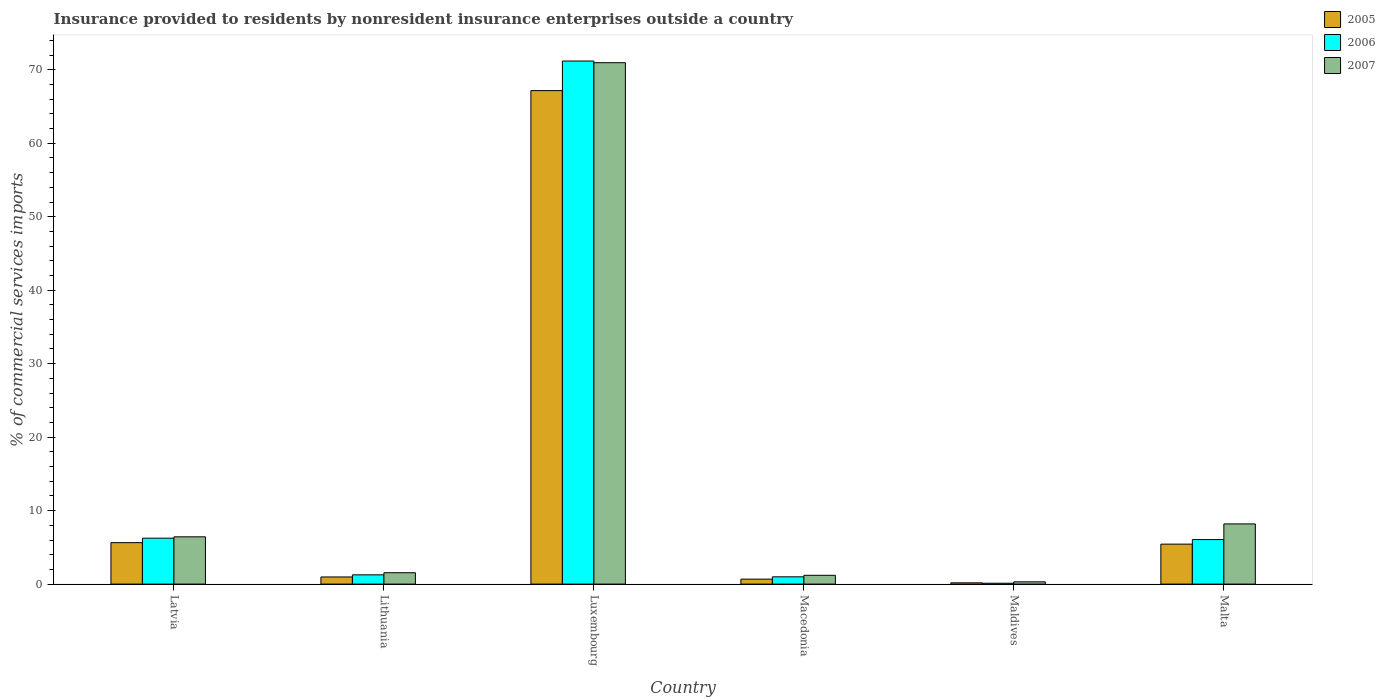Are the number of bars on each tick of the X-axis equal?
Offer a terse response. Yes. How many bars are there on the 3rd tick from the left?
Your answer should be very brief. 3. How many bars are there on the 2nd tick from the right?
Your answer should be very brief. 3. What is the label of the 1st group of bars from the left?
Offer a terse response. Latvia. What is the Insurance provided to residents in 2005 in Luxembourg?
Give a very brief answer. 67.16. Across all countries, what is the maximum Insurance provided to residents in 2006?
Give a very brief answer. 71.19. Across all countries, what is the minimum Insurance provided to residents in 2005?
Give a very brief answer. 0.17. In which country was the Insurance provided to residents in 2006 maximum?
Your answer should be very brief. Luxembourg. In which country was the Insurance provided to residents in 2006 minimum?
Your response must be concise. Maldives. What is the total Insurance provided to residents in 2007 in the graph?
Keep it short and to the point. 88.64. What is the difference between the Insurance provided to residents in 2006 in Maldives and that in Malta?
Give a very brief answer. -5.94. What is the difference between the Insurance provided to residents in 2007 in Macedonia and the Insurance provided to residents in 2006 in Maldives?
Your answer should be very brief. 1.08. What is the average Insurance provided to residents in 2005 per country?
Your answer should be compact. 13.34. What is the difference between the Insurance provided to residents of/in 2006 and Insurance provided to residents of/in 2007 in Luxembourg?
Keep it short and to the point. 0.23. What is the ratio of the Insurance provided to residents in 2005 in Latvia to that in Luxembourg?
Offer a terse response. 0.08. Is the difference between the Insurance provided to residents in 2006 in Macedonia and Malta greater than the difference between the Insurance provided to residents in 2007 in Macedonia and Malta?
Give a very brief answer. Yes. What is the difference between the highest and the second highest Insurance provided to residents in 2005?
Offer a very short reply. -61.72. What is the difference between the highest and the lowest Insurance provided to residents in 2007?
Make the answer very short. 70.65. In how many countries, is the Insurance provided to residents in 2007 greater than the average Insurance provided to residents in 2007 taken over all countries?
Make the answer very short. 1. What does the 3rd bar from the right in Maldives represents?
Your response must be concise. 2005. Is it the case that in every country, the sum of the Insurance provided to residents in 2006 and Insurance provided to residents in 2005 is greater than the Insurance provided to residents in 2007?
Your answer should be very brief. No. How many countries are there in the graph?
Keep it short and to the point. 6. Where does the legend appear in the graph?
Ensure brevity in your answer.  Top right. How many legend labels are there?
Ensure brevity in your answer.  3. What is the title of the graph?
Your response must be concise. Insurance provided to residents by nonresident insurance enterprises outside a country. What is the label or title of the Y-axis?
Give a very brief answer. % of commercial services imports. What is the % of commercial services imports of 2005 in Latvia?
Give a very brief answer. 5.64. What is the % of commercial services imports of 2006 in Latvia?
Provide a succinct answer. 6.25. What is the % of commercial services imports of 2007 in Latvia?
Keep it short and to the point. 6.44. What is the % of commercial services imports of 2005 in Lithuania?
Keep it short and to the point. 0.97. What is the % of commercial services imports in 2006 in Lithuania?
Keep it short and to the point. 1.26. What is the % of commercial services imports of 2007 in Lithuania?
Your answer should be very brief. 1.55. What is the % of commercial services imports of 2005 in Luxembourg?
Your response must be concise. 67.16. What is the % of commercial services imports in 2006 in Luxembourg?
Your answer should be compact. 71.19. What is the % of commercial services imports of 2007 in Luxembourg?
Keep it short and to the point. 70.96. What is the % of commercial services imports of 2005 in Macedonia?
Give a very brief answer. 0.68. What is the % of commercial services imports in 2006 in Macedonia?
Your answer should be compact. 0.99. What is the % of commercial services imports of 2007 in Macedonia?
Provide a succinct answer. 1.2. What is the % of commercial services imports of 2005 in Maldives?
Keep it short and to the point. 0.17. What is the % of commercial services imports of 2006 in Maldives?
Ensure brevity in your answer.  0.12. What is the % of commercial services imports in 2007 in Maldives?
Your answer should be very brief. 0.31. What is the % of commercial services imports of 2005 in Malta?
Make the answer very short. 5.44. What is the % of commercial services imports of 2006 in Malta?
Provide a short and direct response. 6.06. What is the % of commercial services imports of 2007 in Malta?
Your response must be concise. 8.19. Across all countries, what is the maximum % of commercial services imports in 2005?
Ensure brevity in your answer.  67.16. Across all countries, what is the maximum % of commercial services imports of 2006?
Your answer should be very brief. 71.19. Across all countries, what is the maximum % of commercial services imports in 2007?
Ensure brevity in your answer.  70.96. Across all countries, what is the minimum % of commercial services imports in 2005?
Your answer should be very brief. 0.17. Across all countries, what is the minimum % of commercial services imports of 2006?
Provide a short and direct response. 0.12. Across all countries, what is the minimum % of commercial services imports in 2007?
Keep it short and to the point. 0.31. What is the total % of commercial services imports in 2005 in the graph?
Offer a terse response. 80.06. What is the total % of commercial services imports in 2006 in the graph?
Your answer should be compact. 85.86. What is the total % of commercial services imports of 2007 in the graph?
Your response must be concise. 88.64. What is the difference between the % of commercial services imports of 2005 in Latvia and that in Lithuania?
Give a very brief answer. 4.67. What is the difference between the % of commercial services imports in 2006 in Latvia and that in Lithuania?
Provide a succinct answer. 4.99. What is the difference between the % of commercial services imports in 2007 in Latvia and that in Lithuania?
Your answer should be very brief. 4.89. What is the difference between the % of commercial services imports in 2005 in Latvia and that in Luxembourg?
Provide a short and direct response. -61.52. What is the difference between the % of commercial services imports of 2006 in Latvia and that in Luxembourg?
Ensure brevity in your answer.  -64.94. What is the difference between the % of commercial services imports of 2007 in Latvia and that in Luxembourg?
Provide a short and direct response. -64.52. What is the difference between the % of commercial services imports in 2005 in Latvia and that in Macedonia?
Your response must be concise. 4.96. What is the difference between the % of commercial services imports in 2006 in Latvia and that in Macedonia?
Ensure brevity in your answer.  5.26. What is the difference between the % of commercial services imports in 2007 in Latvia and that in Macedonia?
Your answer should be compact. 5.24. What is the difference between the % of commercial services imports in 2005 in Latvia and that in Maldives?
Your answer should be compact. 5.47. What is the difference between the % of commercial services imports in 2006 in Latvia and that in Maldives?
Ensure brevity in your answer.  6.13. What is the difference between the % of commercial services imports in 2007 in Latvia and that in Maldives?
Your answer should be very brief. 6.13. What is the difference between the % of commercial services imports in 2005 in Latvia and that in Malta?
Provide a succinct answer. 0.2. What is the difference between the % of commercial services imports in 2006 in Latvia and that in Malta?
Your response must be concise. 0.19. What is the difference between the % of commercial services imports of 2007 in Latvia and that in Malta?
Provide a short and direct response. -1.76. What is the difference between the % of commercial services imports in 2005 in Lithuania and that in Luxembourg?
Make the answer very short. -66.19. What is the difference between the % of commercial services imports in 2006 in Lithuania and that in Luxembourg?
Your answer should be very brief. -69.92. What is the difference between the % of commercial services imports of 2007 in Lithuania and that in Luxembourg?
Your response must be concise. -69.41. What is the difference between the % of commercial services imports of 2005 in Lithuania and that in Macedonia?
Keep it short and to the point. 0.3. What is the difference between the % of commercial services imports of 2006 in Lithuania and that in Macedonia?
Your response must be concise. 0.27. What is the difference between the % of commercial services imports in 2007 in Lithuania and that in Macedonia?
Offer a terse response. 0.35. What is the difference between the % of commercial services imports of 2005 in Lithuania and that in Maldives?
Offer a terse response. 0.8. What is the difference between the % of commercial services imports in 2006 in Lithuania and that in Maldives?
Ensure brevity in your answer.  1.14. What is the difference between the % of commercial services imports in 2007 in Lithuania and that in Maldives?
Provide a succinct answer. 1.24. What is the difference between the % of commercial services imports in 2005 in Lithuania and that in Malta?
Keep it short and to the point. -4.47. What is the difference between the % of commercial services imports of 2006 in Lithuania and that in Malta?
Give a very brief answer. -4.8. What is the difference between the % of commercial services imports in 2007 in Lithuania and that in Malta?
Ensure brevity in your answer.  -6.64. What is the difference between the % of commercial services imports of 2005 in Luxembourg and that in Macedonia?
Provide a succinct answer. 66.48. What is the difference between the % of commercial services imports in 2006 in Luxembourg and that in Macedonia?
Your answer should be compact. 70.19. What is the difference between the % of commercial services imports in 2007 in Luxembourg and that in Macedonia?
Offer a terse response. 69.76. What is the difference between the % of commercial services imports in 2005 in Luxembourg and that in Maldives?
Your answer should be very brief. 66.99. What is the difference between the % of commercial services imports of 2006 in Luxembourg and that in Maldives?
Your answer should be compact. 71.07. What is the difference between the % of commercial services imports of 2007 in Luxembourg and that in Maldives?
Your answer should be very brief. 70.65. What is the difference between the % of commercial services imports in 2005 in Luxembourg and that in Malta?
Offer a very short reply. 61.72. What is the difference between the % of commercial services imports in 2006 in Luxembourg and that in Malta?
Ensure brevity in your answer.  65.12. What is the difference between the % of commercial services imports in 2007 in Luxembourg and that in Malta?
Your answer should be compact. 62.77. What is the difference between the % of commercial services imports in 2005 in Macedonia and that in Maldives?
Ensure brevity in your answer.  0.5. What is the difference between the % of commercial services imports in 2006 in Macedonia and that in Maldives?
Provide a short and direct response. 0.87. What is the difference between the % of commercial services imports of 2007 in Macedonia and that in Maldives?
Your response must be concise. 0.89. What is the difference between the % of commercial services imports of 2005 in Macedonia and that in Malta?
Your answer should be compact. -4.76. What is the difference between the % of commercial services imports in 2006 in Macedonia and that in Malta?
Provide a succinct answer. -5.07. What is the difference between the % of commercial services imports of 2007 in Macedonia and that in Malta?
Ensure brevity in your answer.  -6.99. What is the difference between the % of commercial services imports in 2005 in Maldives and that in Malta?
Make the answer very short. -5.27. What is the difference between the % of commercial services imports in 2006 in Maldives and that in Malta?
Keep it short and to the point. -5.94. What is the difference between the % of commercial services imports of 2007 in Maldives and that in Malta?
Ensure brevity in your answer.  -7.88. What is the difference between the % of commercial services imports in 2005 in Latvia and the % of commercial services imports in 2006 in Lithuania?
Give a very brief answer. 4.38. What is the difference between the % of commercial services imports in 2005 in Latvia and the % of commercial services imports in 2007 in Lithuania?
Provide a short and direct response. 4.09. What is the difference between the % of commercial services imports in 2006 in Latvia and the % of commercial services imports in 2007 in Lithuania?
Your answer should be compact. 4.7. What is the difference between the % of commercial services imports in 2005 in Latvia and the % of commercial services imports in 2006 in Luxembourg?
Offer a terse response. -65.54. What is the difference between the % of commercial services imports of 2005 in Latvia and the % of commercial services imports of 2007 in Luxembourg?
Ensure brevity in your answer.  -65.32. What is the difference between the % of commercial services imports in 2006 in Latvia and the % of commercial services imports in 2007 in Luxembourg?
Offer a very short reply. -64.71. What is the difference between the % of commercial services imports of 2005 in Latvia and the % of commercial services imports of 2006 in Macedonia?
Provide a succinct answer. 4.65. What is the difference between the % of commercial services imports in 2005 in Latvia and the % of commercial services imports in 2007 in Macedonia?
Keep it short and to the point. 4.44. What is the difference between the % of commercial services imports of 2006 in Latvia and the % of commercial services imports of 2007 in Macedonia?
Your answer should be very brief. 5.05. What is the difference between the % of commercial services imports of 2005 in Latvia and the % of commercial services imports of 2006 in Maldives?
Provide a succinct answer. 5.52. What is the difference between the % of commercial services imports of 2005 in Latvia and the % of commercial services imports of 2007 in Maldives?
Offer a terse response. 5.33. What is the difference between the % of commercial services imports of 2006 in Latvia and the % of commercial services imports of 2007 in Maldives?
Provide a short and direct response. 5.94. What is the difference between the % of commercial services imports in 2005 in Latvia and the % of commercial services imports in 2006 in Malta?
Your answer should be compact. -0.42. What is the difference between the % of commercial services imports in 2005 in Latvia and the % of commercial services imports in 2007 in Malta?
Offer a terse response. -2.55. What is the difference between the % of commercial services imports in 2006 in Latvia and the % of commercial services imports in 2007 in Malta?
Provide a short and direct response. -1.94. What is the difference between the % of commercial services imports in 2005 in Lithuania and the % of commercial services imports in 2006 in Luxembourg?
Make the answer very short. -70.21. What is the difference between the % of commercial services imports of 2005 in Lithuania and the % of commercial services imports of 2007 in Luxembourg?
Your answer should be compact. -69.99. What is the difference between the % of commercial services imports in 2006 in Lithuania and the % of commercial services imports in 2007 in Luxembourg?
Your response must be concise. -69.7. What is the difference between the % of commercial services imports in 2005 in Lithuania and the % of commercial services imports in 2006 in Macedonia?
Offer a terse response. -0.02. What is the difference between the % of commercial services imports of 2005 in Lithuania and the % of commercial services imports of 2007 in Macedonia?
Give a very brief answer. -0.23. What is the difference between the % of commercial services imports of 2006 in Lithuania and the % of commercial services imports of 2007 in Macedonia?
Offer a terse response. 0.06. What is the difference between the % of commercial services imports of 2005 in Lithuania and the % of commercial services imports of 2006 in Maldives?
Offer a very short reply. 0.85. What is the difference between the % of commercial services imports in 2005 in Lithuania and the % of commercial services imports in 2007 in Maldives?
Provide a short and direct response. 0.66. What is the difference between the % of commercial services imports of 2006 in Lithuania and the % of commercial services imports of 2007 in Maldives?
Offer a very short reply. 0.95. What is the difference between the % of commercial services imports of 2005 in Lithuania and the % of commercial services imports of 2006 in Malta?
Offer a terse response. -5.09. What is the difference between the % of commercial services imports in 2005 in Lithuania and the % of commercial services imports in 2007 in Malta?
Provide a succinct answer. -7.22. What is the difference between the % of commercial services imports in 2006 in Lithuania and the % of commercial services imports in 2007 in Malta?
Provide a succinct answer. -6.93. What is the difference between the % of commercial services imports of 2005 in Luxembourg and the % of commercial services imports of 2006 in Macedonia?
Make the answer very short. 66.17. What is the difference between the % of commercial services imports of 2005 in Luxembourg and the % of commercial services imports of 2007 in Macedonia?
Make the answer very short. 65.96. What is the difference between the % of commercial services imports in 2006 in Luxembourg and the % of commercial services imports in 2007 in Macedonia?
Your answer should be compact. 69.99. What is the difference between the % of commercial services imports in 2005 in Luxembourg and the % of commercial services imports in 2006 in Maldives?
Make the answer very short. 67.04. What is the difference between the % of commercial services imports of 2005 in Luxembourg and the % of commercial services imports of 2007 in Maldives?
Provide a succinct answer. 66.85. What is the difference between the % of commercial services imports of 2006 in Luxembourg and the % of commercial services imports of 2007 in Maldives?
Your response must be concise. 70.88. What is the difference between the % of commercial services imports of 2005 in Luxembourg and the % of commercial services imports of 2006 in Malta?
Offer a very short reply. 61.1. What is the difference between the % of commercial services imports of 2005 in Luxembourg and the % of commercial services imports of 2007 in Malta?
Give a very brief answer. 58.97. What is the difference between the % of commercial services imports of 2006 in Luxembourg and the % of commercial services imports of 2007 in Malta?
Give a very brief answer. 62.99. What is the difference between the % of commercial services imports in 2005 in Macedonia and the % of commercial services imports in 2006 in Maldives?
Your answer should be compact. 0.56. What is the difference between the % of commercial services imports of 2005 in Macedonia and the % of commercial services imports of 2007 in Maldives?
Offer a terse response. 0.37. What is the difference between the % of commercial services imports of 2006 in Macedonia and the % of commercial services imports of 2007 in Maldives?
Offer a very short reply. 0.68. What is the difference between the % of commercial services imports of 2005 in Macedonia and the % of commercial services imports of 2006 in Malta?
Your answer should be very brief. -5.38. What is the difference between the % of commercial services imports of 2005 in Macedonia and the % of commercial services imports of 2007 in Malta?
Provide a short and direct response. -7.52. What is the difference between the % of commercial services imports in 2006 in Macedonia and the % of commercial services imports in 2007 in Malta?
Your answer should be very brief. -7.2. What is the difference between the % of commercial services imports of 2005 in Maldives and the % of commercial services imports of 2006 in Malta?
Your answer should be compact. -5.89. What is the difference between the % of commercial services imports of 2005 in Maldives and the % of commercial services imports of 2007 in Malta?
Your answer should be compact. -8.02. What is the difference between the % of commercial services imports of 2006 in Maldives and the % of commercial services imports of 2007 in Malta?
Ensure brevity in your answer.  -8.07. What is the average % of commercial services imports in 2005 per country?
Give a very brief answer. 13.34. What is the average % of commercial services imports in 2006 per country?
Give a very brief answer. 14.31. What is the average % of commercial services imports in 2007 per country?
Make the answer very short. 14.77. What is the difference between the % of commercial services imports in 2005 and % of commercial services imports in 2006 in Latvia?
Keep it short and to the point. -0.61. What is the difference between the % of commercial services imports of 2005 and % of commercial services imports of 2007 in Latvia?
Give a very brief answer. -0.79. What is the difference between the % of commercial services imports in 2006 and % of commercial services imports in 2007 in Latvia?
Ensure brevity in your answer.  -0.19. What is the difference between the % of commercial services imports of 2005 and % of commercial services imports of 2006 in Lithuania?
Ensure brevity in your answer.  -0.29. What is the difference between the % of commercial services imports of 2005 and % of commercial services imports of 2007 in Lithuania?
Your answer should be compact. -0.57. What is the difference between the % of commercial services imports of 2006 and % of commercial services imports of 2007 in Lithuania?
Your answer should be compact. -0.29. What is the difference between the % of commercial services imports of 2005 and % of commercial services imports of 2006 in Luxembourg?
Your response must be concise. -4.03. What is the difference between the % of commercial services imports of 2005 and % of commercial services imports of 2007 in Luxembourg?
Ensure brevity in your answer.  -3.8. What is the difference between the % of commercial services imports of 2006 and % of commercial services imports of 2007 in Luxembourg?
Your answer should be very brief. 0.23. What is the difference between the % of commercial services imports of 2005 and % of commercial services imports of 2006 in Macedonia?
Your answer should be very brief. -0.31. What is the difference between the % of commercial services imports of 2005 and % of commercial services imports of 2007 in Macedonia?
Provide a succinct answer. -0.52. What is the difference between the % of commercial services imports in 2006 and % of commercial services imports in 2007 in Macedonia?
Your answer should be very brief. -0.21. What is the difference between the % of commercial services imports in 2005 and % of commercial services imports in 2006 in Maldives?
Your answer should be compact. 0.05. What is the difference between the % of commercial services imports in 2005 and % of commercial services imports in 2007 in Maldives?
Your answer should be very brief. -0.14. What is the difference between the % of commercial services imports of 2006 and % of commercial services imports of 2007 in Maldives?
Provide a succinct answer. -0.19. What is the difference between the % of commercial services imports of 2005 and % of commercial services imports of 2006 in Malta?
Make the answer very short. -0.62. What is the difference between the % of commercial services imports of 2005 and % of commercial services imports of 2007 in Malta?
Keep it short and to the point. -2.75. What is the difference between the % of commercial services imports of 2006 and % of commercial services imports of 2007 in Malta?
Make the answer very short. -2.13. What is the ratio of the % of commercial services imports in 2005 in Latvia to that in Lithuania?
Keep it short and to the point. 5.8. What is the ratio of the % of commercial services imports of 2006 in Latvia to that in Lithuania?
Keep it short and to the point. 4.96. What is the ratio of the % of commercial services imports in 2007 in Latvia to that in Lithuania?
Your answer should be compact. 4.16. What is the ratio of the % of commercial services imports of 2005 in Latvia to that in Luxembourg?
Your answer should be compact. 0.08. What is the ratio of the % of commercial services imports of 2006 in Latvia to that in Luxembourg?
Your response must be concise. 0.09. What is the ratio of the % of commercial services imports in 2007 in Latvia to that in Luxembourg?
Make the answer very short. 0.09. What is the ratio of the % of commercial services imports in 2005 in Latvia to that in Macedonia?
Your answer should be compact. 8.34. What is the ratio of the % of commercial services imports in 2006 in Latvia to that in Macedonia?
Your answer should be very brief. 6.31. What is the ratio of the % of commercial services imports in 2007 in Latvia to that in Macedonia?
Provide a succinct answer. 5.37. What is the ratio of the % of commercial services imports of 2005 in Latvia to that in Maldives?
Offer a terse response. 32.8. What is the ratio of the % of commercial services imports in 2006 in Latvia to that in Maldives?
Provide a short and direct response. 53.06. What is the ratio of the % of commercial services imports in 2007 in Latvia to that in Maldives?
Offer a very short reply. 20.87. What is the ratio of the % of commercial services imports of 2006 in Latvia to that in Malta?
Provide a succinct answer. 1.03. What is the ratio of the % of commercial services imports of 2007 in Latvia to that in Malta?
Offer a terse response. 0.79. What is the ratio of the % of commercial services imports of 2005 in Lithuania to that in Luxembourg?
Give a very brief answer. 0.01. What is the ratio of the % of commercial services imports in 2006 in Lithuania to that in Luxembourg?
Make the answer very short. 0.02. What is the ratio of the % of commercial services imports in 2007 in Lithuania to that in Luxembourg?
Your answer should be compact. 0.02. What is the ratio of the % of commercial services imports in 2005 in Lithuania to that in Macedonia?
Make the answer very short. 1.44. What is the ratio of the % of commercial services imports in 2006 in Lithuania to that in Macedonia?
Offer a terse response. 1.27. What is the ratio of the % of commercial services imports in 2007 in Lithuania to that in Macedonia?
Your answer should be very brief. 1.29. What is the ratio of the % of commercial services imports in 2005 in Lithuania to that in Maldives?
Give a very brief answer. 5.66. What is the ratio of the % of commercial services imports in 2006 in Lithuania to that in Maldives?
Ensure brevity in your answer.  10.7. What is the ratio of the % of commercial services imports of 2007 in Lithuania to that in Maldives?
Make the answer very short. 5.02. What is the ratio of the % of commercial services imports of 2005 in Lithuania to that in Malta?
Offer a very short reply. 0.18. What is the ratio of the % of commercial services imports of 2006 in Lithuania to that in Malta?
Keep it short and to the point. 0.21. What is the ratio of the % of commercial services imports of 2007 in Lithuania to that in Malta?
Give a very brief answer. 0.19. What is the ratio of the % of commercial services imports of 2005 in Luxembourg to that in Macedonia?
Your answer should be compact. 99.34. What is the ratio of the % of commercial services imports in 2006 in Luxembourg to that in Macedonia?
Provide a succinct answer. 71.88. What is the ratio of the % of commercial services imports of 2007 in Luxembourg to that in Macedonia?
Offer a very short reply. 59.22. What is the ratio of the % of commercial services imports of 2005 in Luxembourg to that in Maldives?
Make the answer very short. 390.52. What is the ratio of the % of commercial services imports of 2006 in Luxembourg to that in Maldives?
Your answer should be very brief. 604.38. What is the ratio of the % of commercial services imports of 2007 in Luxembourg to that in Maldives?
Keep it short and to the point. 230.12. What is the ratio of the % of commercial services imports of 2005 in Luxembourg to that in Malta?
Provide a succinct answer. 12.35. What is the ratio of the % of commercial services imports in 2006 in Luxembourg to that in Malta?
Your answer should be very brief. 11.74. What is the ratio of the % of commercial services imports in 2007 in Luxembourg to that in Malta?
Keep it short and to the point. 8.66. What is the ratio of the % of commercial services imports in 2005 in Macedonia to that in Maldives?
Provide a short and direct response. 3.93. What is the ratio of the % of commercial services imports of 2006 in Macedonia to that in Maldives?
Provide a short and direct response. 8.41. What is the ratio of the % of commercial services imports of 2007 in Macedonia to that in Maldives?
Offer a very short reply. 3.89. What is the ratio of the % of commercial services imports of 2005 in Macedonia to that in Malta?
Your response must be concise. 0.12. What is the ratio of the % of commercial services imports of 2006 in Macedonia to that in Malta?
Offer a very short reply. 0.16. What is the ratio of the % of commercial services imports in 2007 in Macedonia to that in Malta?
Your answer should be very brief. 0.15. What is the ratio of the % of commercial services imports of 2005 in Maldives to that in Malta?
Give a very brief answer. 0.03. What is the ratio of the % of commercial services imports in 2006 in Maldives to that in Malta?
Give a very brief answer. 0.02. What is the ratio of the % of commercial services imports in 2007 in Maldives to that in Malta?
Your response must be concise. 0.04. What is the difference between the highest and the second highest % of commercial services imports of 2005?
Your response must be concise. 61.52. What is the difference between the highest and the second highest % of commercial services imports in 2006?
Provide a succinct answer. 64.94. What is the difference between the highest and the second highest % of commercial services imports of 2007?
Ensure brevity in your answer.  62.77. What is the difference between the highest and the lowest % of commercial services imports of 2005?
Keep it short and to the point. 66.99. What is the difference between the highest and the lowest % of commercial services imports in 2006?
Make the answer very short. 71.07. What is the difference between the highest and the lowest % of commercial services imports of 2007?
Your response must be concise. 70.65. 